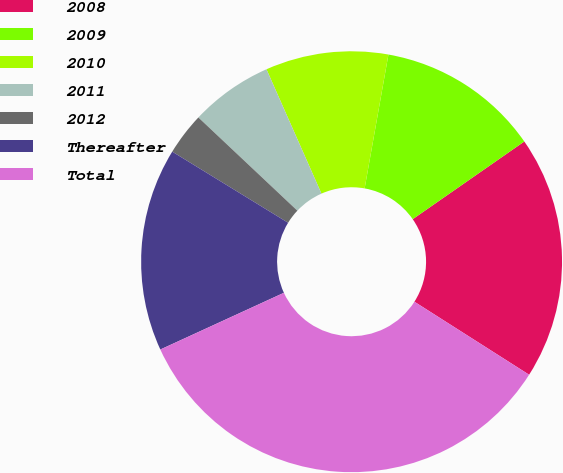<chart> <loc_0><loc_0><loc_500><loc_500><pie_chart><fcel>2008<fcel>2009<fcel>2010<fcel>2011<fcel>2012<fcel>Thereafter<fcel>Total<nl><fcel>18.7%<fcel>12.52%<fcel>9.43%<fcel>6.35%<fcel>3.26%<fcel>15.61%<fcel>34.13%<nl></chart> 